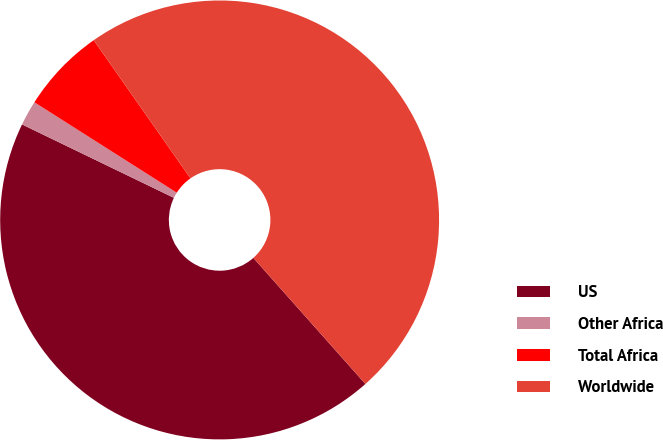<chart> <loc_0><loc_0><loc_500><loc_500><pie_chart><fcel>US<fcel>Other Africa<fcel>Total Africa<fcel>Worldwide<nl><fcel>43.73%<fcel>1.84%<fcel>6.27%<fcel>48.16%<nl></chart> 